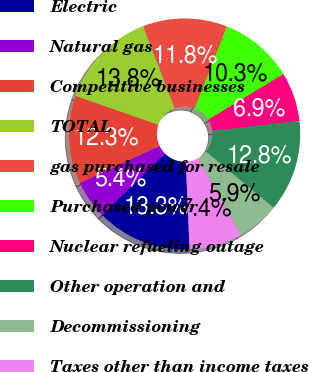Convert chart to OTSL. <chart><loc_0><loc_0><loc_500><loc_500><pie_chart><fcel>Electric<fcel>Natural gas<fcel>Competitive businesses<fcel>TOTAL<fcel>gas purchased for resale<fcel>Purchased power<fcel>Nuclear refueling outage<fcel>Other operation and<fcel>Decommissioning<fcel>Taxes other than income taxes<nl><fcel>13.3%<fcel>5.42%<fcel>12.32%<fcel>13.79%<fcel>11.82%<fcel>10.34%<fcel>6.9%<fcel>12.81%<fcel>5.91%<fcel>7.39%<nl></chart> 